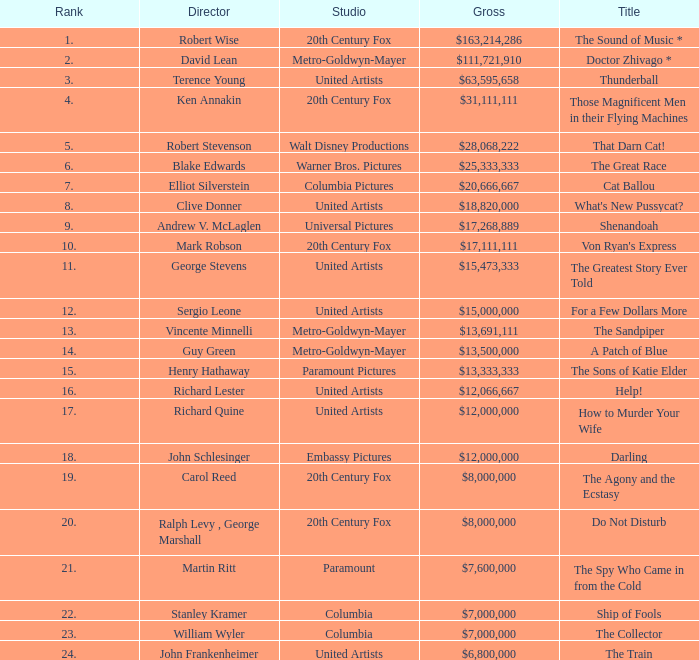What is the highest Rank, when Director is "Henry Hathaway"? 15.0. 